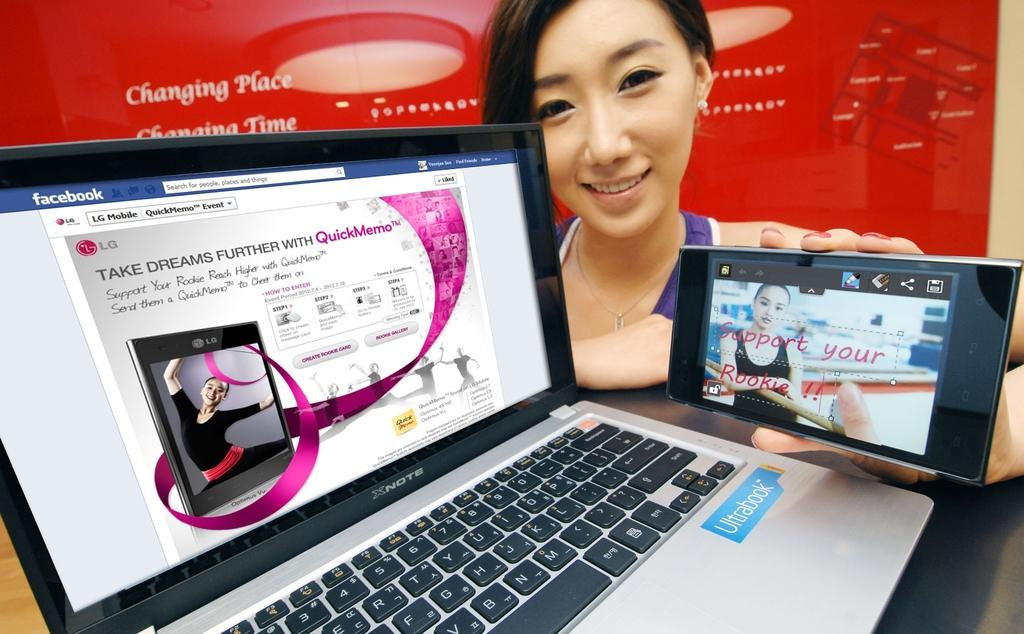<image>
Relay a brief, clear account of the picture shown. a woman holding a phone next to a laptop featuring a webpage from LG 